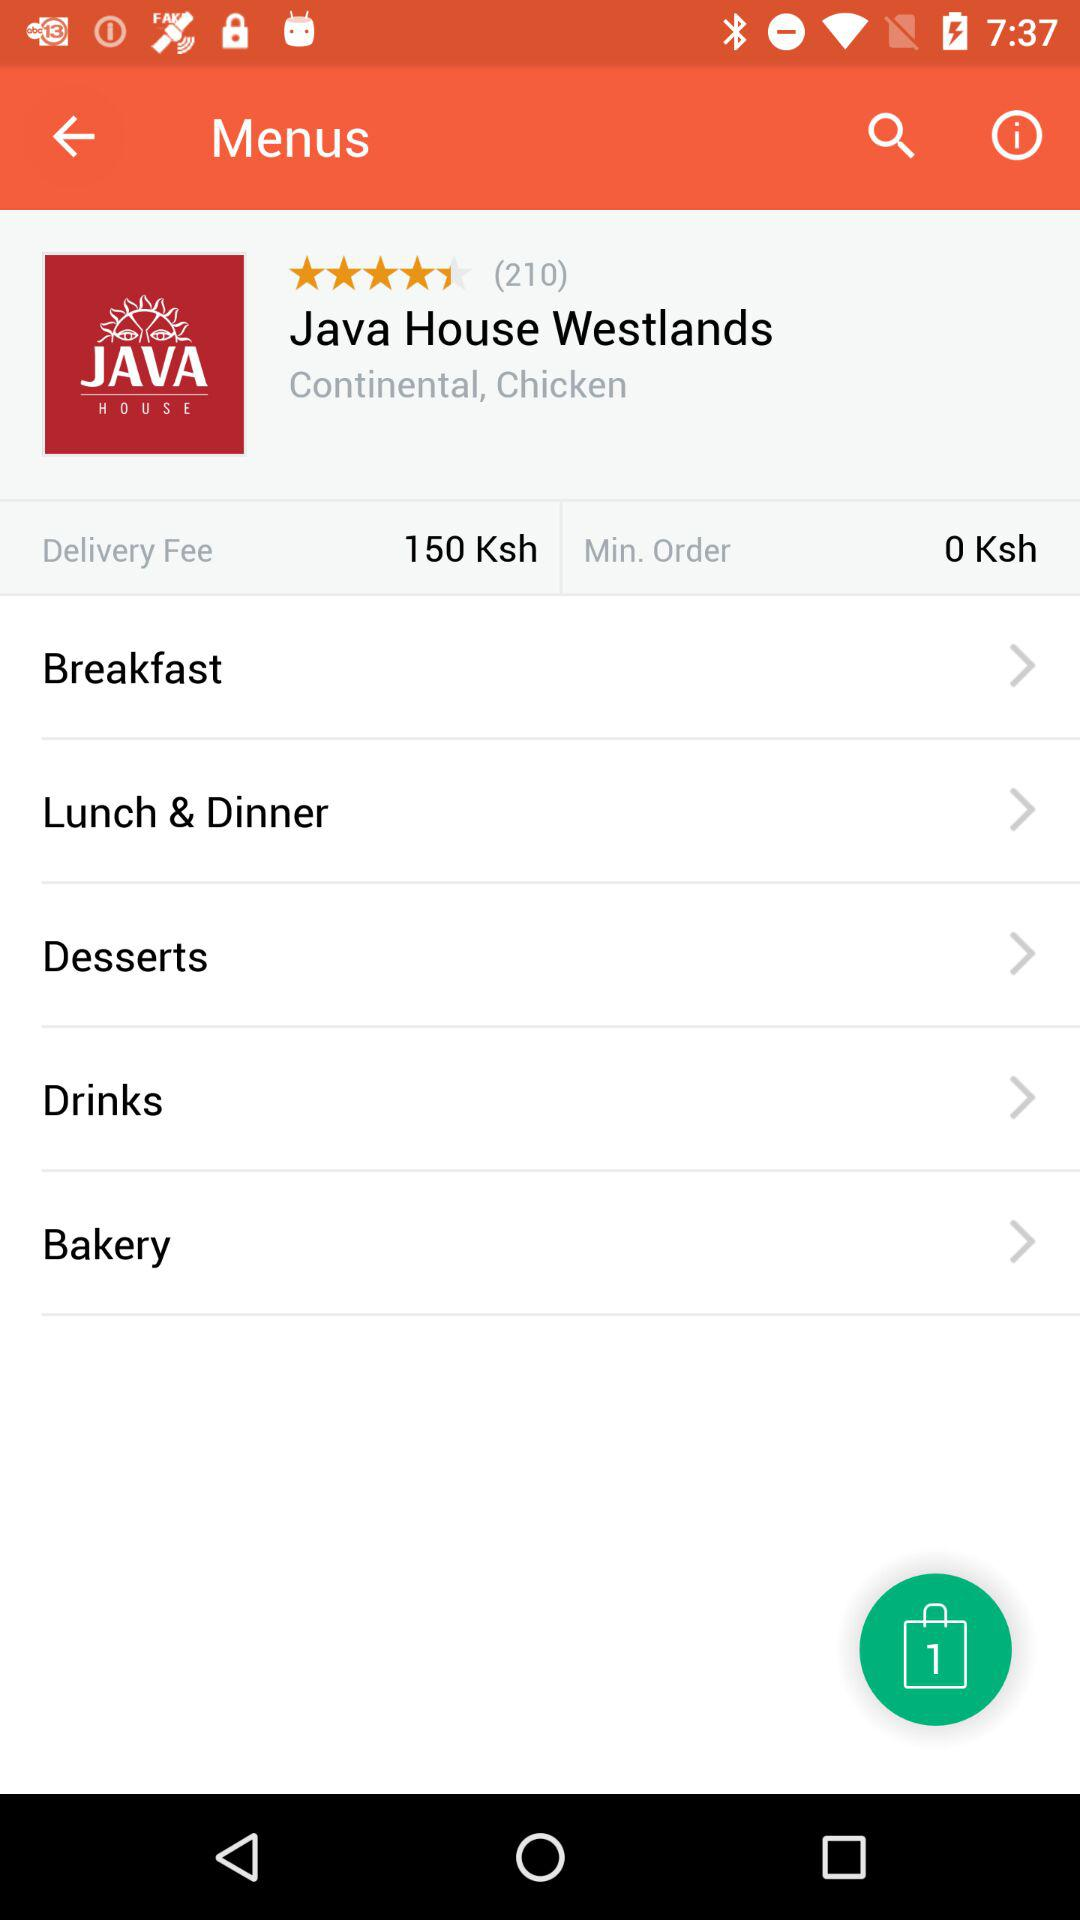How much is the delivery fee?
Answer the question using a single word or phrase. 150 Ksh 